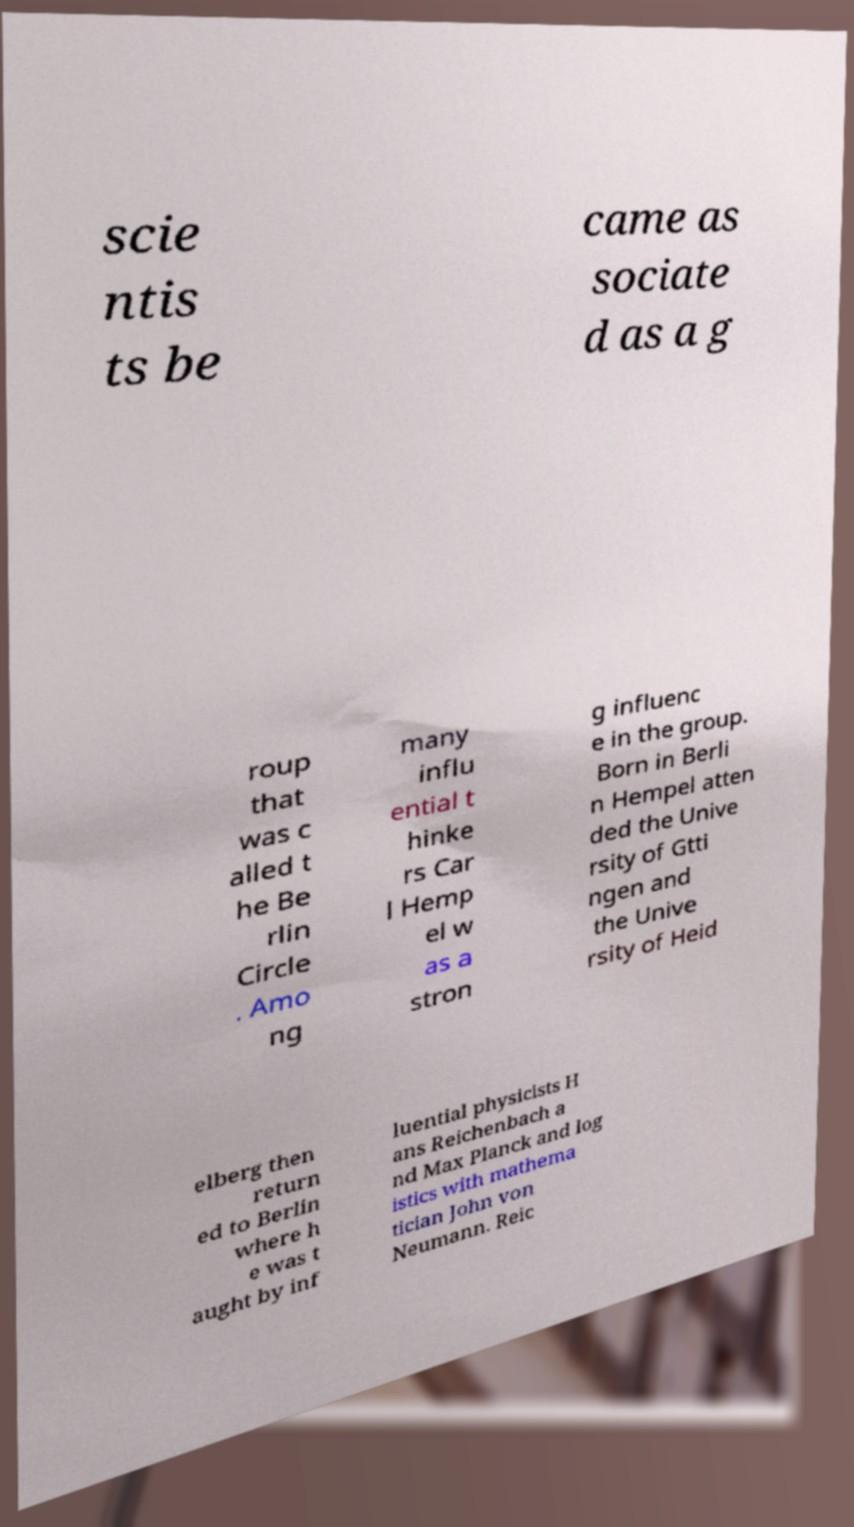There's text embedded in this image that I need extracted. Can you transcribe it verbatim? scie ntis ts be came as sociate d as a g roup that was c alled t he Be rlin Circle . Amo ng many influ ential t hinke rs Car l Hemp el w as a stron g influenc e in the group. Born in Berli n Hempel atten ded the Unive rsity of Gtti ngen and the Unive rsity of Heid elberg then return ed to Berlin where h e was t aught by inf luential physicists H ans Reichenbach a nd Max Planck and log istics with mathema tician John von Neumann. Reic 